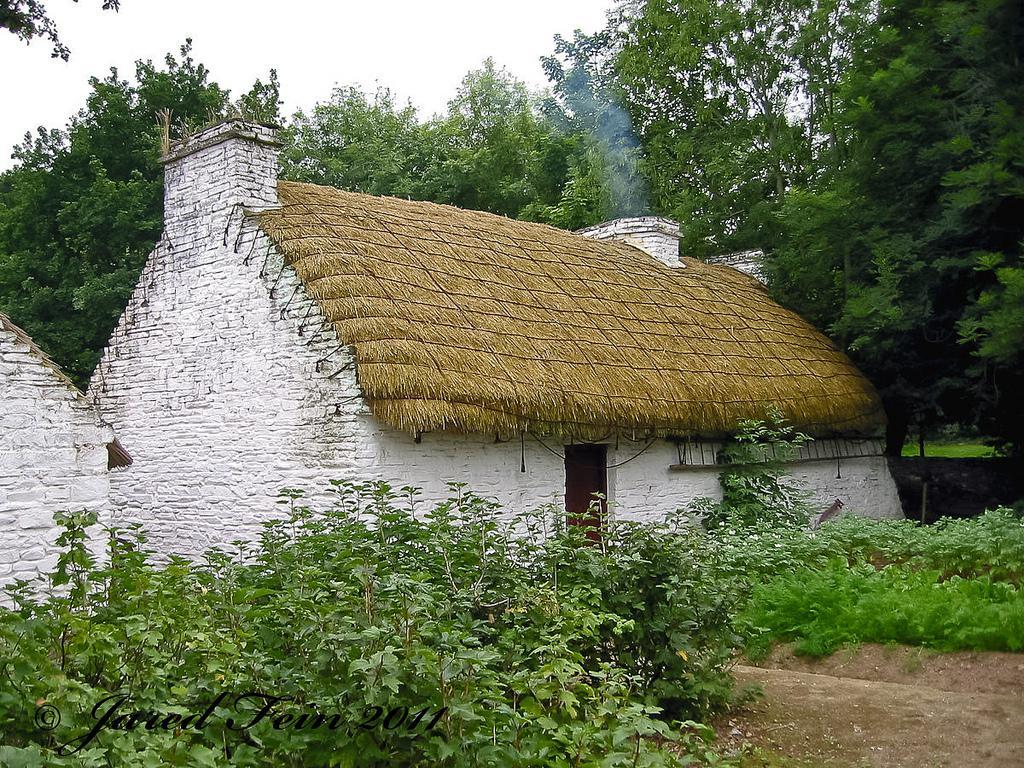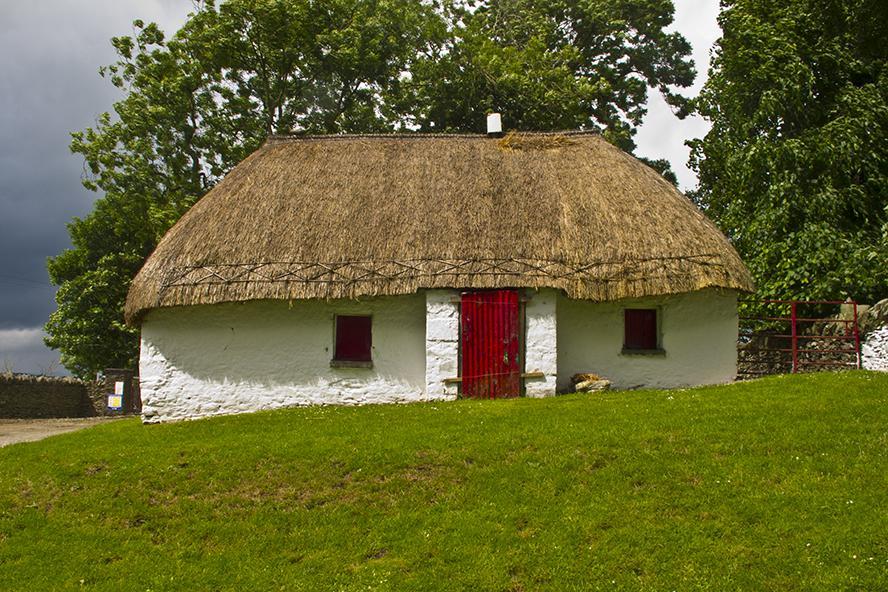The first image is the image on the left, the second image is the image on the right. Examine the images to the left and right. Is the description "The left and right image contains the same number of buildings with at least one red door." accurate? Answer yes or no. Yes. The first image is the image on the left, the second image is the image on the right. Analyze the images presented: Is the assertion "A house has a red door." valid? Answer yes or no. Yes. 